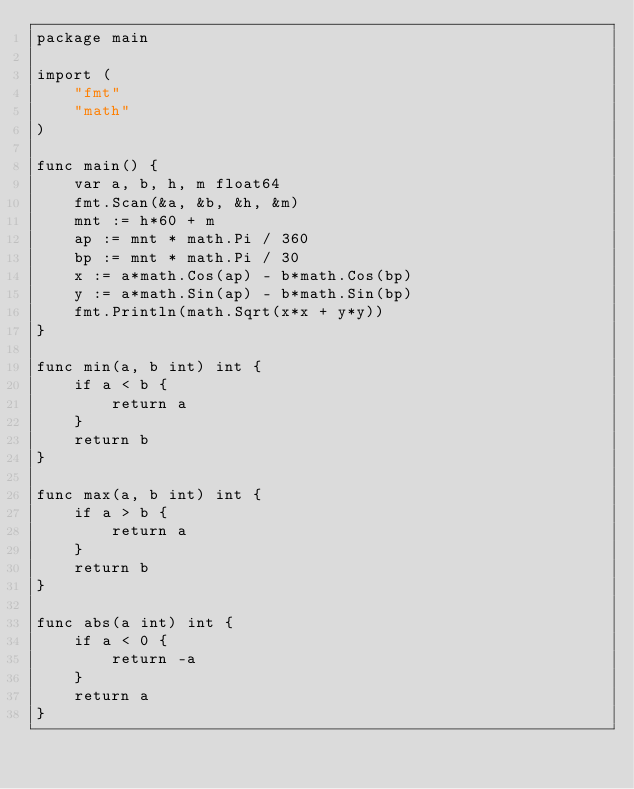Convert code to text. <code><loc_0><loc_0><loc_500><loc_500><_Go_>package main

import (
	"fmt"
	"math"
)

func main() {
	var a, b, h, m float64
	fmt.Scan(&a, &b, &h, &m)
	mnt := h*60 + m
	ap := mnt * math.Pi / 360
	bp := mnt * math.Pi / 30
	x := a*math.Cos(ap) - b*math.Cos(bp)
	y := a*math.Sin(ap) - b*math.Sin(bp)
	fmt.Println(math.Sqrt(x*x + y*y))
}

func min(a, b int) int {
	if a < b {
		return a
	}
	return b
}

func max(a, b int) int {
	if a > b {
		return a
	}
	return b
}

func abs(a int) int {
	if a < 0 {
		return -a
	}
	return a
}
</code> 